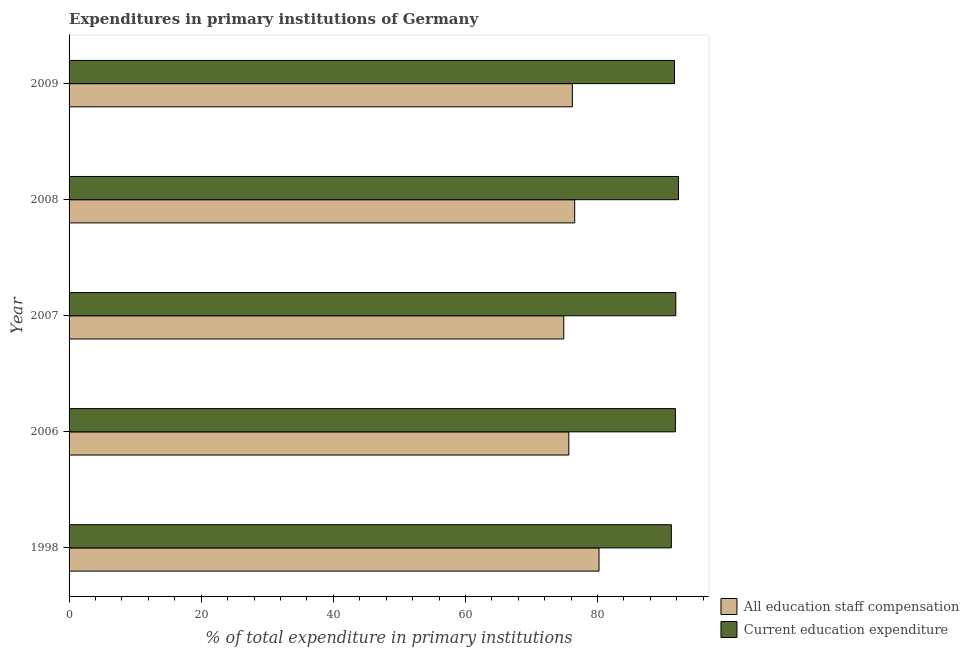How many groups of bars are there?
Offer a terse response. 5. Are the number of bars per tick equal to the number of legend labels?
Make the answer very short. Yes. Are the number of bars on each tick of the Y-axis equal?
Ensure brevity in your answer.  Yes. What is the label of the 4th group of bars from the top?
Provide a short and direct response. 2006. What is the expenditure in education in 1998?
Offer a very short reply. 91.17. Across all years, what is the maximum expenditure in education?
Your response must be concise. 92.25. Across all years, what is the minimum expenditure in education?
Ensure brevity in your answer.  91.17. In which year was the expenditure in staff compensation maximum?
Offer a terse response. 1998. What is the total expenditure in education in the graph?
Provide a succinct answer. 458.71. What is the difference between the expenditure in education in 2006 and that in 2007?
Your answer should be very brief. -0.06. What is the difference between the expenditure in staff compensation in 1998 and the expenditure in education in 2007?
Ensure brevity in your answer.  -11.63. What is the average expenditure in education per year?
Offer a very short reply. 91.74. In the year 2008, what is the difference between the expenditure in staff compensation and expenditure in education?
Ensure brevity in your answer.  -15.71. What is the ratio of the expenditure in staff compensation in 2006 to that in 2008?
Keep it short and to the point. 0.99. Is the expenditure in staff compensation in 2006 less than that in 2009?
Give a very brief answer. Yes. Is the difference between the expenditure in education in 2008 and 2009 greater than the difference between the expenditure in staff compensation in 2008 and 2009?
Keep it short and to the point. Yes. What is the difference between the highest and the second highest expenditure in education?
Make the answer very short. 0.4. What is the difference between the highest and the lowest expenditure in staff compensation?
Ensure brevity in your answer.  5.34. Is the sum of the expenditure in education in 1998 and 2008 greater than the maximum expenditure in staff compensation across all years?
Give a very brief answer. Yes. What does the 1st bar from the top in 2006 represents?
Your answer should be compact. Current education expenditure. What does the 1st bar from the bottom in 2008 represents?
Your answer should be compact. All education staff compensation. What is the difference between two consecutive major ticks on the X-axis?
Provide a succinct answer. 20. Are the values on the major ticks of X-axis written in scientific E-notation?
Ensure brevity in your answer.  No. Does the graph contain any zero values?
Keep it short and to the point. No. Does the graph contain grids?
Offer a terse response. No. Where does the legend appear in the graph?
Keep it short and to the point. Bottom right. How are the legend labels stacked?
Make the answer very short. Vertical. What is the title of the graph?
Offer a very short reply. Expenditures in primary institutions of Germany. Does "Register a business" appear as one of the legend labels in the graph?
Ensure brevity in your answer.  No. What is the label or title of the X-axis?
Provide a succinct answer. % of total expenditure in primary institutions. What is the label or title of the Y-axis?
Keep it short and to the point. Year. What is the % of total expenditure in primary institutions in All education staff compensation in 1998?
Offer a terse response. 80.22. What is the % of total expenditure in primary institutions of Current education expenditure in 1998?
Provide a succinct answer. 91.17. What is the % of total expenditure in primary institutions in All education staff compensation in 2006?
Your answer should be compact. 75.65. What is the % of total expenditure in primary institutions of Current education expenditure in 2006?
Offer a terse response. 91.79. What is the % of total expenditure in primary institutions in All education staff compensation in 2007?
Your response must be concise. 74.88. What is the % of total expenditure in primary institutions in Current education expenditure in 2007?
Make the answer very short. 91.85. What is the % of total expenditure in primary institutions in All education staff compensation in 2008?
Provide a short and direct response. 76.54. What is the % of total expenditure in primary institutions of Current education expenditure in 2008?
Provide a succinct answer. 92.25. What is the % of total expenditure in primary institutions in All education staff compensation in 2009?
Offer a terse response. 76.19. What is the % of total expenditure in primary institutions of Current education expenditure in 2009?
Ensure brevity in your answer.  91.65. Across all years, what is the maximum % of total expenditure in primary institutions in All education staff compensation?
Make the answer very short. 80.22. Across all years, what is the maximum % of total expenditure in primary institutions of Current education expenditure?
Provide a short and direct response. 92.25. Across all years, what is the minimum % of total expenditure in primary institutions in All education staff compensation?
Provide a short and direct response. 74.88. Across all years, what is the minimum % of total expenditure in primary institutions in Current education expenditure?
Make the answer very short. 91.17. What is the total % of total expenditure in primary institutions in All education staff compensation in the graph?
Your answer should be compact. 383.49. What is the total % of total expenditure in primary institutions in Current education expenditure in the graph?
Provide a short and direct response. 458.71. What is the difference between the % of total expenditure in primary institutions of All education staff compensation in 1998 and that in 2006?
Your answer should be very brief. 4.57. What is the difference between the % of total expenditure in primary institutions in Current education expenditure in 1998 and that in 2006?
Your answer should be very brief. -0.61. What is the difference between the % of total expenditure in primary institutions in All education staff compensation in 1998 and that in 2007?
Offer a very short reply. 5.34. What is the difference between the % of total expenditure in primary institutions in Current education expenditure in 1998 and that in 2007?
Ensure brevity in your answer.  -0.68. What is the difference between the % of total expenditure in primary institutions in All education staff compensation in 1998 and that in 2008?
Make the answer very short. 3.68. What is the difference between the % of total expenditure in primary institutions in Current education expenditure in 1998 and that in 2008?
Provide a short and direct response. -1.08. What is the difference between the % of total expenditure in primary institutions of All education staff compensation in 1998 and that in 2009?
Offer a very short reply. 4.03. What is the difference between the % of total expenditure in primary institutions of Current education expenditure in 1998 and that in 2009?
Your response must be concise. -0.48. What is the difference between the % of total expenditure in primary institutions in All education staff compensation in 2006 and that in 2007?
Provide a succinct answer. 0.77. What is the difference between the % of total expenditure in primary institutions in Current education expenditure in 2006 and that in 2007?
Offer a terse response. -0.06. What is the difference between the % of total expenditure in primary institutions in All education staff compensation in 2006 and that in 2008?
Provide a short and direct response. -0.89. What is the difference between the % of total expenditure in primary institutions of Current education expenditure in 2006 and that in 2008?
Offer a terse response. -0.46. What is the difference between the % of total expenditure in primary institutions of All education staff compensation in 2006 and that in 2009?
Offer a terse response. -0.53. What is the difference between the % of total expenditure in primary institutions of Current education expenditure in 2006 and that in 2009?
Offer a terse response. 0.14. What is the difference between the % of total expenditure in primary institutions of All education staff compensation in 2007 and that in 2008?
Keep it short and to the point. -1.65. What is the difference between the % of total expenditure in primary institutions in Current education expenditure in 2007 and that in 2008?
Provide a succinct answer. -0.4. What is the difference between the % of total expenditure in primary institutions in All education staff compensation in 2007 and that in 2009?
Give a very brief answer. -1.3. What is the difference between the % of total expenditure in primary institutions of Current education expenditure in 2007 and that in 2009?
Your answer should be compact. 0.2. What is the difference between the % of total expenditure in primary institutions in All education staff compensation in 2008 and that in 2009?
Offer a terse response. 0.35. What is the difference between the % of total expenditure in primary institutions in Current education expenditure in 2008 and that in 2009?
Your answer should be compact. 0.6. What is the difference between the % of total expenditure in primary institutions of All education staff compensation in 1998 and the % of total expenditure in primary institutions of Current education expenditure in 2006?
Provide a short and direct response. -11.56. What is the difference between the % of total expenditure in primary institutions in All education staff compensation in 1998 and the % of total expenditure in primary institutions in Current education expenditure in 2007?
Offer a very short reply. -11.63. What is the difference between the % of total expenditure in primary institutions in All education staff compensation in 1998 and the % of total expenditure in primary institutions in Current education expenditure in 2008?
Your response must be concise. -12.03. What is the difference between the % of total expenditure in primary institutions in All education staff compensation in 1998 and the % of total expenditure in primary institutions in Current education expenditure in 2009?
Provide a succinct answer. -11.43. What is the difference between the % of total expenditure in primary institutions in All education staff compensation in 2006 and the % of total expenditure in primary institutions in Current education expenditure in 2007?
Your answer should be compact. -16.19. What is the difference between the % of total expenditure in primary institutions of All education staff compensation in 2006 and the % of total expenditure in primary institutions of Current education expenditure in 2008?
Give a very brief answer. -16.6. What is the difference between the % of total expenditure in primary institutions in All education staff compensation in 2006 and the % of total expenditure in primary institutions in Current education expenditure in 2009?
Your answer should be very brief. -16. What is the difference between the % of total expenditure in primary institutions of All education staff compensation in 2007 and the % of total expenditure in primary institutions of Current education expenditure in 2008?
Your answer should be very brief. -17.37. What is the difference between the % of total expenditure in primary institutions in All education staff compensation in 2007 and the % of total expenditure in primary institutions in Current education expenditure in 2009?
Your response must be concise. -16.77. What is the difference between the % of total expenditure in primary institutions of All education staff compensation in 2008 and the % of total expenditure in primary institutions of Current education expenditure in 2009?
Provide a succinct answer. -15.11. What is the average % of total expenditure in primary institutions in All education staff compensation per year?
Offer a terse response. 76.7. What is the average % of total expenditure in primary institutions in Current education expenditure per year?
Provide a succinct answer. 91.74. In the year 1998, what is the difference between the % of total expenditure in primary institutions in All education staff compensation and % of total expenditure in primary institutions in Current education expenditure?
Provide a short and direct response. -10.95. In the year 2006, what is the difference between the % of total expenditure in primary institutions in All education staff compensation and % of total expenditure in primary institutions in Current education expenditure?
Provide a short and direct response. -16.13. In the year 2007, what is the difference between the % of total expenditure in primary institutions of All education staff compensation and % of total expenditure in primary institutions of Current education expenditure?
Make the answer very short. -16.96. In the year 2008, what is the difference between the % of total expenditure in primary institutions in All education staff compensation and % of total expenditure in primary institutions in Current education expenditure?
Provide a succinct answer. -15.71. In the year 2009, what is the difference between the % of total expenditure in primary institutions of All education staff compensation and % of total expenditure in primary institutions of Current education expenditure?
Provide a short and direct response. -15.46. What is the ratio of the % of total expenditure in primary institutions in All education staff compensation in 1998 to that in 2006?
Your answer should be very brief. 1.06. What is the ratio of the % of total expenditure in primary institutions in Current education expenditure in 1998 to that in 2006?
Ensure brevity in your answer.  0.99. What is the ratio of the % of total expenditure in primary institutions of All education staff compensation in 1998 to that in 2007?
Provide a succinct answer. 1.07. What is the ratio of the % of total expenditure in primary institutions in All education staff compensation in 1998 to that in 2008?
Give a very brief answer. 1.05. What is the ratio of the % of total expenditure in primary institutions in Current education expenditure in 1998 to that in 2008?
Your answer should be compact. 0.99. What is the ratio of the % of total expenditure in primary institutions of All education staff compensation in 1998 to that in 2009?
Offer a very short reply. 1.05. What is the ratio of the % of total expenditure in primary institutions of All education staff compensation in 2006 to that in 2007?
Offer a terse response. 1.01. What is the ratio of the % of total expenditure in primary institutions of All education staff compensation in 2006 to that in 2008?
Keep it short and to the point. 0.99. What is the ratio of the % of total expenditure in primary institutions in Current education expenditure in 2006 to that in 2008?
Make the answer very short. 0.99. What is the ratio of the % of total expenditure in primary institutions of All education staff compensation in 2006 to that in 2009?
Offer a terse response. 0.99. What is the ratio of the % of total expenditure in primary institutions in Current education expenditure in 2006 to that in 2009?
Offer a terse response. 1. What is the ratio of the % of total expenditure in primary institutions in All education staff compensation in 2007 to that in 2008?
Ensure brevity in your answer.  0.98. What is the ratio of the % of total expenditure in primary institutions in All education staff compensation in 2007 to that in 2009?
Provide a short and direct response. 0.98. What is the ratio of the % of total expenditure in primary institutions in Current education expenditure in 2007 to that in 2009?
Offer a very short reply. 1. What is the ratio of the % of total expenditure in primary institutions in All education staff compensation in 2008 to that in 2009?
Your response must be concise. 1. What is the ratio of the % of total expenditure in primary institutions in Current education expenditure in 2008 to that in 2009?
Keep it short and to the point. 1.01. What is the difference between the highest and the second highest % of total expenditure in primary institutions in All education staff compensation?
Offer a very short reply. 3.68. What is the difference between the highest and the second highest % of total expenditure in primary institutions of Current education expenditure?
Keep it short and to the point. 0.4. What is the difference between the highest and the lowest % of total expenditure in primary institutions of All education staff compensation?
Offer a terse response. 5.34. What is the difference between the highest and the lowest % of total expenditure in primary institutions of Current education expenditure?
Your answer should be compact. 1.08. 